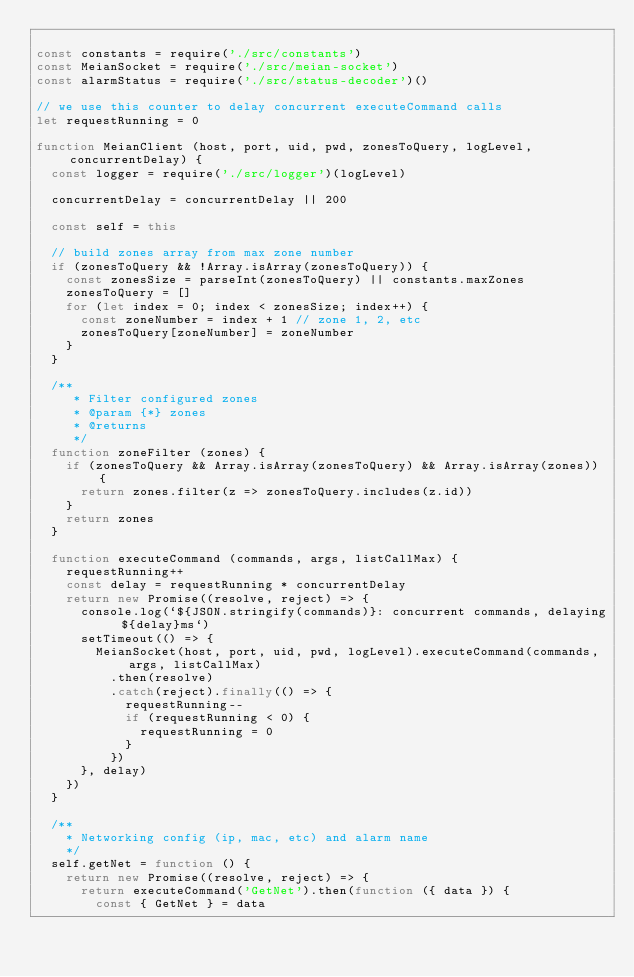<code> <loc_0><loc_0><loc_500><loc_500><_JavaScript_>
const constants = require('./src/constants')
const MeianSocket = require('./src/meian-socket')
const alarmStatus = require('./src/status-decoder')()

// we use this counter to delay concurrent executeCommand calls
let requestRunning = 0

function MeianClient (host, port, uid, pwd, zonesToQuery, logLevel, concurrentDelay) {
  const logger = require('./src/logger')(logLevel)

  concurrentDelay = concurrentDelay || 200

  const self = this

  // build zones array from max zone number
  if (zonesToQuery && !Array.isArray(zonesToQuery)) {
    const zonesSize = parseInt(zonesToQuery) || constants.maxZones
    zonesToQuery = []
    for (let index = 0; index < zonesSize; index++) {
      const zoneNumber = index + 1 // zone 1, 2, etc
      zonesToQuery[zoneNumber] = zoneNumber
    }
  }

  /**
     * Filter configured zones
     * @param {*} zones
     * @returns
     */
  function zoneFilter (zones) {
    if (zonesToQuery && Array.isArray(zonesToQuery) && Array.isArray(zones)) {
      return zones.filter(z => zonesToQuery.includes(z.id))
    }
    return zones
  }

  function executeCommand (commands, args, listCallMax) {
    requestRunning++
    const delay = requestRunning * concurrentDelay
    return new Promise((resolve, reject) => {
      console.log(`${JSON.stringify(commands)}: concurrent commands, delaying ${delay}ms`)
      setTimeout(() => {
        MeianSocket(host, port, uid, pwd, logLevel).executeCommand(commands, args, listCallMax)
          .then(resolve)
          .catch(reject).finally(() => {
            requestRunning--
            if (requestRunning < 0) {
              requestRunning = 0
            }
          })
      }, delay)
    })
  }

  /**
    * Networking config (ip, mac, etc) and alarm name
    */
  self.getNet = function () {
    return new Promise((resolve, reject) => {
      return executeCommand('GetNet').then(function ({ data }) {
        const { GetNet } = data</code> 